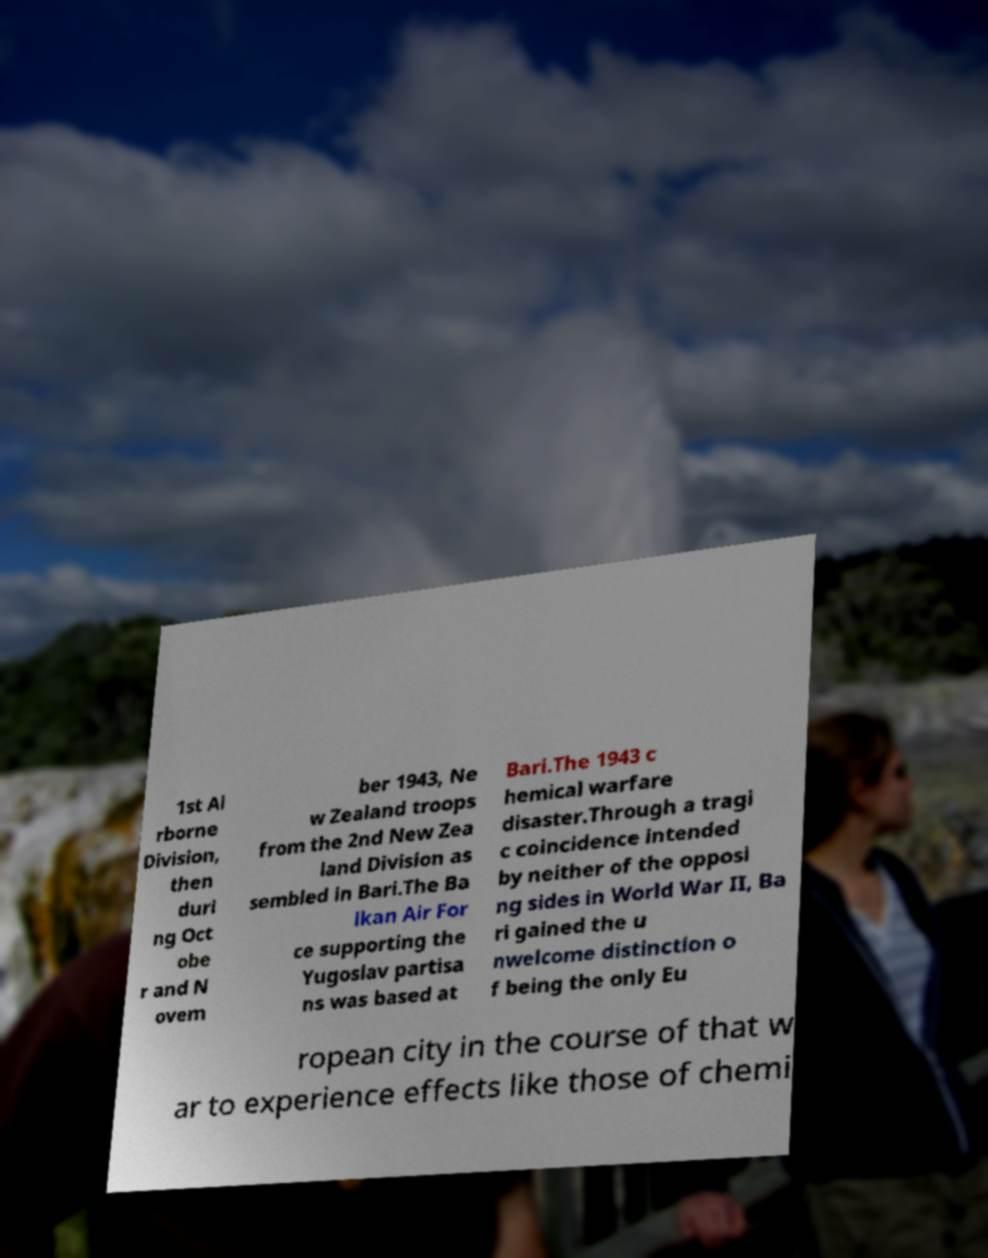There's text embedded in this image that I need extracted. Can you transcribe it verbatim? 1st Ai rborne Division, then duri ng Oct obe r and N ovem ber 1943, Ne w Zealand troops from the 2nd New Zea land Division as sembled in Bari.The Ba lkan Air For ce supporting the Yugoslav partisa ns was based at Bari.The 1943 c hemical warfare disaster.Through a tragi c coincidence intended by neither of the opposi ng sides in World War II, Ba ri gained the u nwelcome distinction o f being the only Eu ropean city in the course of that w ar to experience effects like those of chemi 